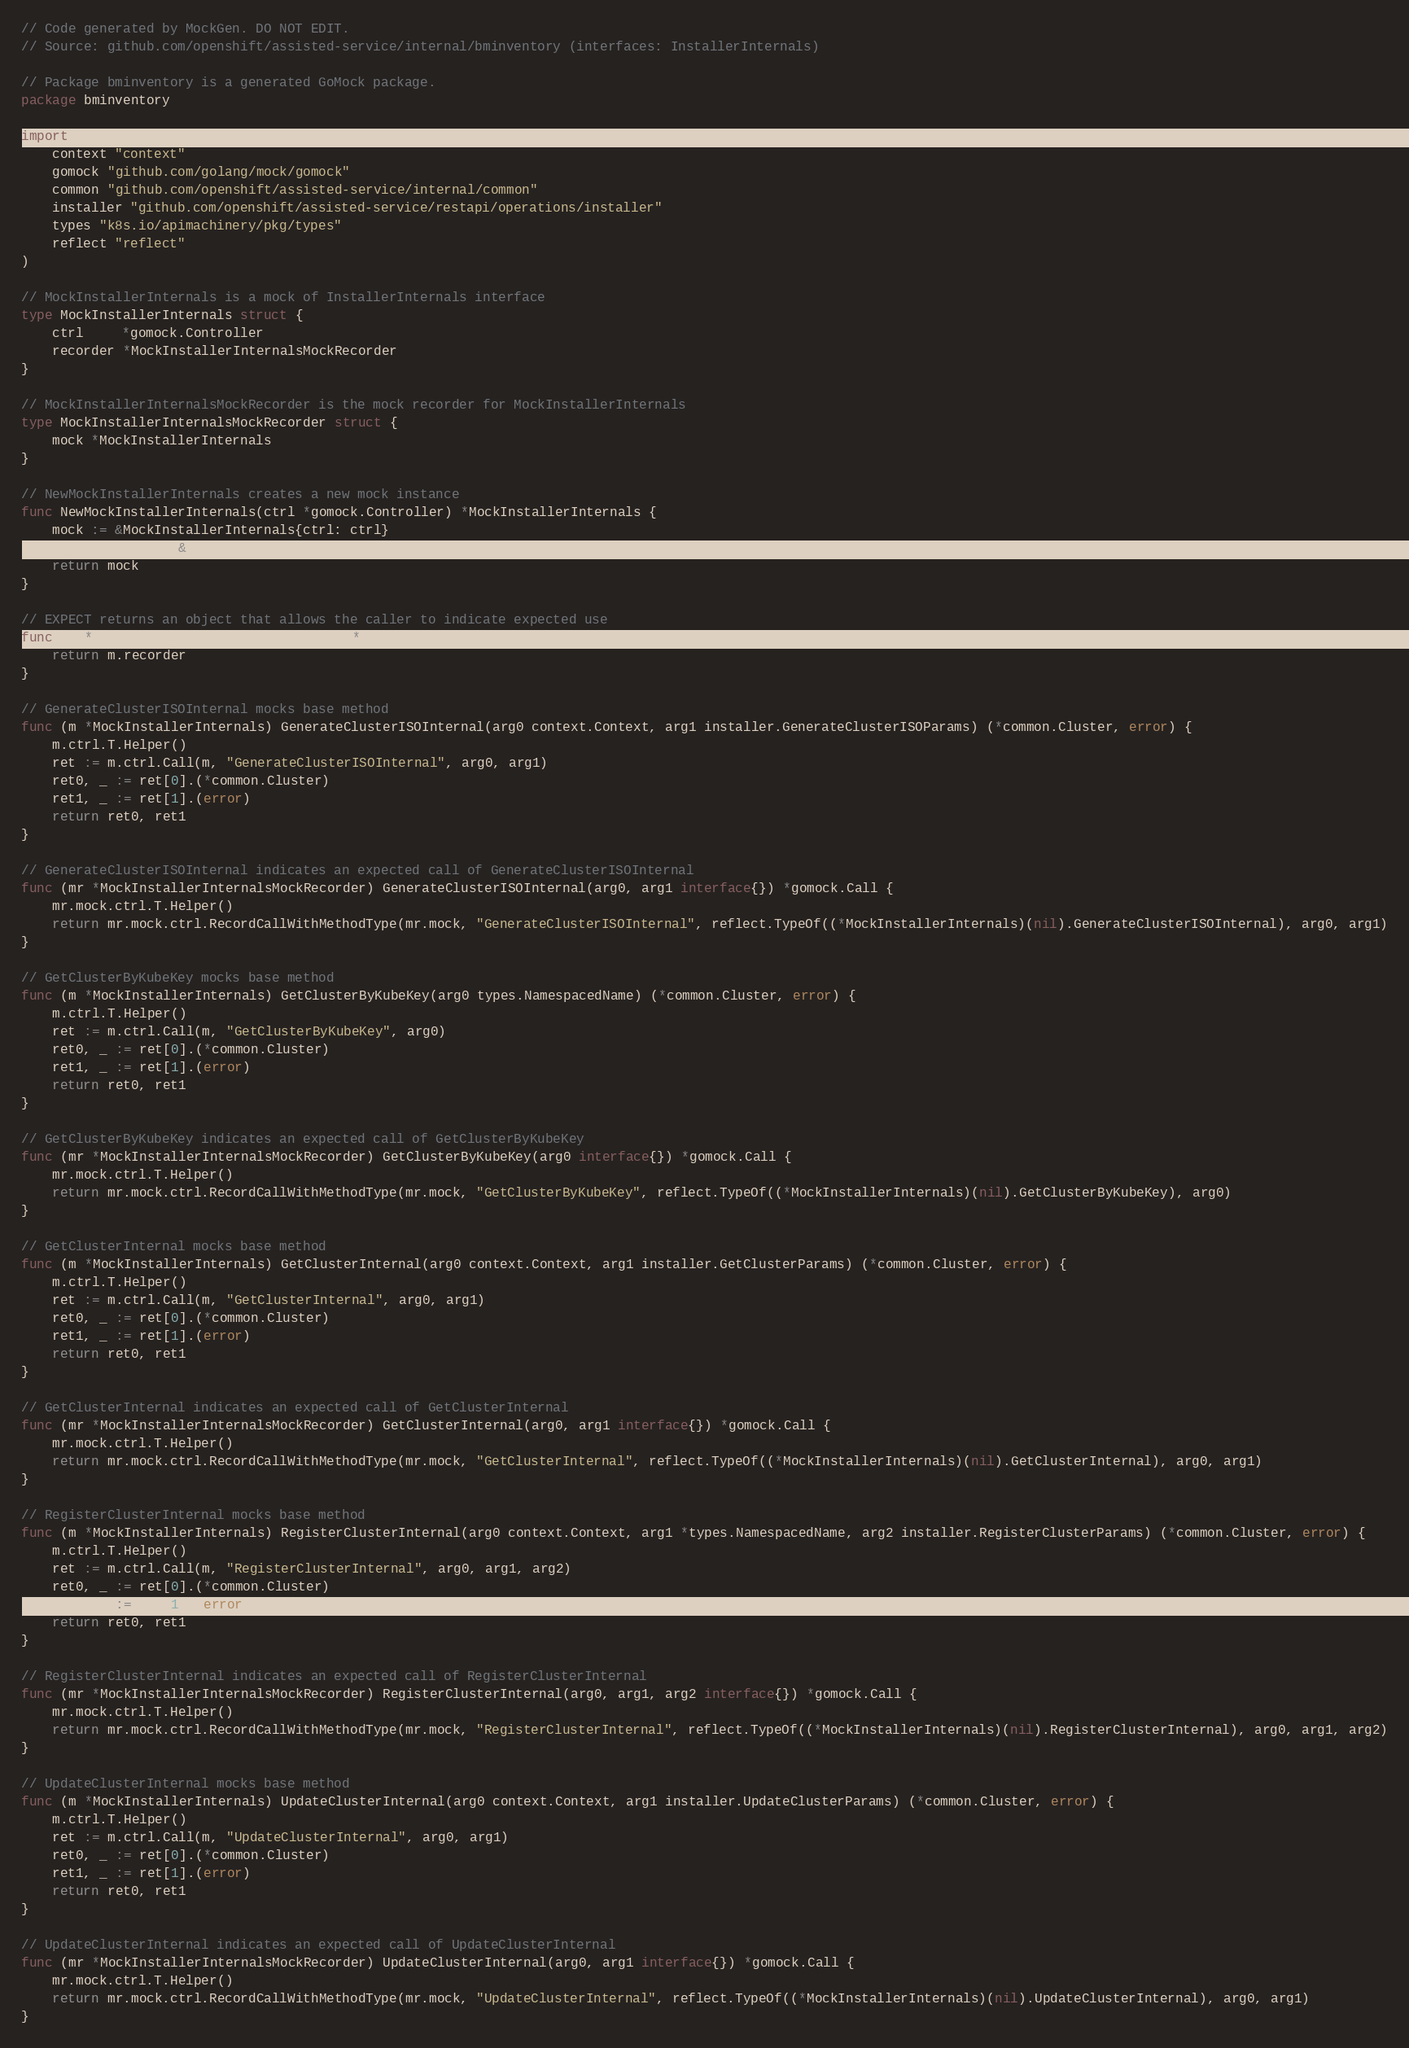Convert code to text. <code><loc_0><loc_0><loc_500><loc_500><_Go_>// Code generated by MockGen. DO NOT EDIT.
// Source: github.com/openshift/assisted-service/internal/bminventory (interfaces: InstallerInternals)

// Package bminventory is a generated GoMock package.
package bminventory

import (
	context "context"
	gomock "github.com/golang/mock/gomock"
	common "github.com/openshift/assisted-service/internal/common"
	installer "github.com/openshift/assisted-service/restapi/operations/installer"
	types "k8s.io/apimachinery/pkg/types"
	reflect "reflect"
)

// MockInstallerInternals is a mock of InstallerInternals interface
type MockInstallerInternals struct {
	ctrl     *gomock.Controller
	recorder *MockInstallerInternalsMockRecorder
}

// MockInstallerInternalsMockRecorder is the mock recorder for MockInstallerInternals
type MockInstallerInternalsMockRecorder struct {
	mock *MockInstallerInternals
}

// NewMockInstallerInternals creates a new mock instance
func NewMockInstallerInternals(ctrl *gomock.Controller) *MockInstallerInternals {
	mock := &MockInstallerInternals{ctrl: ctrl}
	mock.recorder = &MockInstallerInternalsMockRecorder{mock}
	return mock
}

// EXPECT returns an object that allows the caller to indicate expected use
func (m *MockInstallerInternals) EXPECT() *MockInstallerInternalsMockRecorder {
	return m.recorder
}

// GenerateClusterISOInternal mocks base method
func (m *MockInstallerInternals) GenerateClusterISOInternal(arg0 context.Context, arg1 installer.GenerateClusterISOParams) (*common.Cluster, error) {
	m.ctrl.T.Helper()
	ret := m.ctrl.Call(m, "GenerateClusterISOInternal", arg0, arg1)
	ret0, _ := ret[0].(*common.Cluster)
	ret1, _ := ret[1].(error)
	return ret0, ret1
}

// GenerateClusterISOInternal indicates an expected call of GenerateClusterISOInternal
func (mr *MockInstallerInternalsMockRecorder) GenerateClusterISOInternal(arg0, arg1 interface{}) *gomock.Call {
	mr.mock.ctrl.T.Helper()
	return mr.mock.ctrl.RecordCallWithMethodType(mr.mock, "GenerateClusterISOInternal", reflect.TypeOf((*MockInstallerInternals)(nil).GenerateClusterISOInternal), arg0, arg1)
}

// GetClusterByKubeKey mocks base method
func (m *MockInstallerInternals) GetClusterByKubeKey(arg0 types.NamespacedName) (*common.Cluster, error) {
	m.ctrl.T.Helper()
	ret := m.ctrl.Call(m, "GetClusterByKubeKey", arg0)
	ret0, _ := ret[0].(*common.Cluster)
	ret1, _ := ret[1].(error)
	return ret0, ret1
}

// GetClusterByKubeKey indicates an expected call of GetClusterByKubeKey
func (mr *MockInstallerInternalsMockRecorder) GetClusterByKubeKey(arg0 interface{}) *gomock.Call {
	mr.mock.ctrl.T.Helper()
	return mr.mock.ctrl.RecordCallWithMethodType(mr.mock, "GetClusterByKubeKey", reflect.TypeOf((*MockInstallerInternals)(nil).GetClusterByKubeKey), arg0)
}

// GetClusterInternal mocks base method
func (m *MockInstallerInternals) GetClusterInternal(arg0 context.Context, arg1 installer.GetClusterParams) (*common.Cluster, error) {
	m.ctrl.T.Helper()
	ret := m.ctrl.Call(m, "GetClusterInternal", arg0, arg1)
	ret0, _ := ret[0].(*common.Cluster)
	ret1, _ := ret[1].(error)
	return ret0, ret1
}

// GetClusterInternal indicates an expected call of GetClusterInternal
func (mr *MockInstallerInternalsMockRecorder) GetClusterInternal(arg0, arg1 interface{}) *gomock.Call {
	mr.mock.ctrl.T.Helper()
	return mr.mock.ctrl.RecordCallWithMethodType(mr.mock, "GetClusterInternal", reflect.TypeOf((*MockInstallerInternals)(nil).GetClusterInternal), arg0, arg1)
}

// RegisterClusterInternal mocks base method
func (m *MockInstallerInternals) RegisterClusterInternal(arg0 context.Context, arg1 *types.NamespacedName, arg2 installer.RegisterClusterParams) (*common.Cluster, error) {
	m.ctrl.T.Helper()
	ret := m.ctrl.Call(m, "RegisterClusterInternal", arg0, arg1, arg2)
	ret0, _ := ret[0].(*common.Cluster)
	ret1, _ := ret[1].(error)
	return ret0, ret1
}

// RegisterClusterInternal indicates an expected call of RegisterClusterInternal
func (mr *MockInstallerInternalsMockRecorder) RegisterClusterInternal(arg0, arg1, arg2 interface{}) *gomock.Call {
	mr.mock.ctrl.T.Helper()
	return mr.mock.ctrl.RecordCallWithMethodType(mr.mock, "RegisterClusterInternal", reflect.TypeOf((*MockInstallerInternals)(nil).RegisterClusterInternal), arg0, arg1, arg2)
}

// UpdateClusterInternal mocks base method
func (m *MockInstallerInternals) UpdateClusterInternal(arg0 context.Context, arg1 installer.UpdateClusterParams) (*common.Cluster, error) {
	m.ctrl.T.Helper()
	ret := m.ctrl.Call(m, "UpdateClusterInternal", arg0, arg1)
	ret0, _ := ret[0].(*common.Cluster)
	ret1, _ := ret[1].(error)
	return ret0, ret1
}

// UpdateClusterInternal indicates an expected call of UpdateClusterInternal
func (mr *MockInstallerInternalsMockRecorder) UpdateClusterInternal(arg0, arg1 interface{}) *gomock.Call {
	mr.mock.ctrl.T.Helper()
	return mr.mock.ctrl.RecordCallWithMethodType(mr.mock, "UpdateClusterInternal", reflect.TypeOf((*MockInstallerInternals)(nil).UpdateClusterInternal), arg0, arg1)
}
</code> 